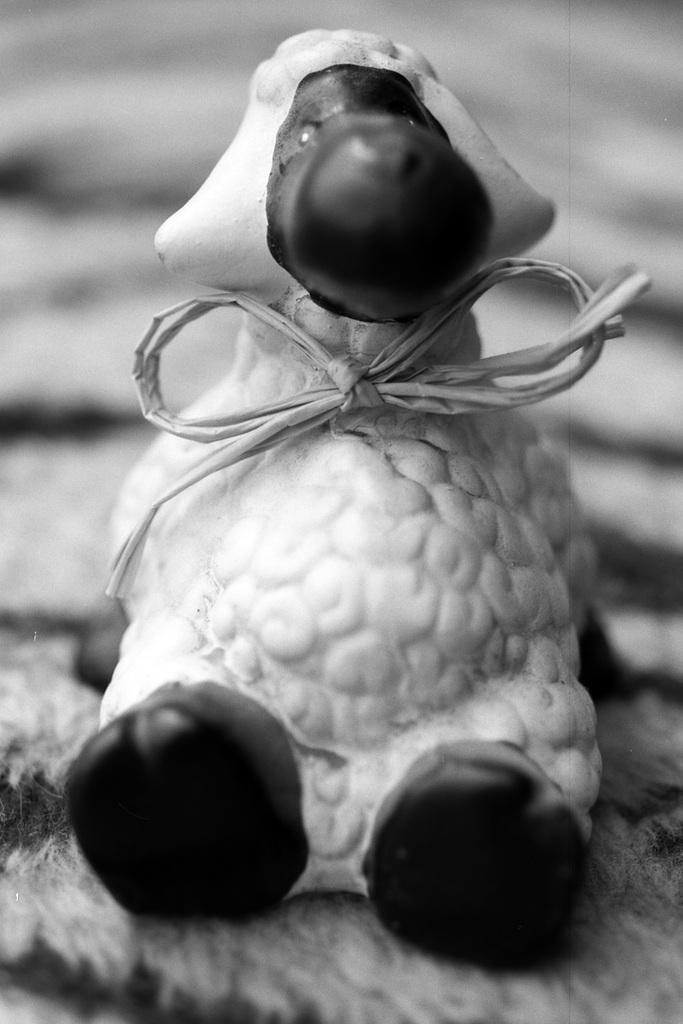What is the main subject in the image? There is a doll in the image. Where is the doll located in the image? The doll is in the center of the image. What type of sign is the doll holding in the image? There is no sign present in the image; the doll is not holding anything. Is there a fight happening between the doll and another object in the image? There is no fight depicted in the image; the doll is simply located in the center. Does the doll have a crown on its head in the image? There is no crown present on the doll's head in the image. 